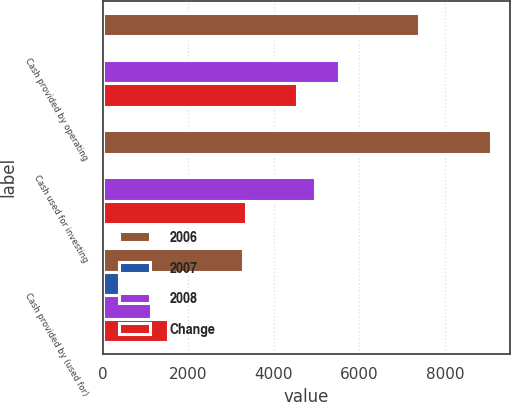Convert chart to OTSL. <chart><loc_0><loc_0><loc_500><loc_500><stacked_bar_chart><ecel><fcel>Cash provided by operating<fcel>Cash used for investing<fcel>Cash provided by (used for)<nl><fcel>2006<fcel>7402<fcel>9076<fcel>3281<nl><fcel>2007<fcel>34<fcel>83<fcel>388<nl><fcel>2008<fcel>5520<fcel>4971<fcel>1139<nl><fcel>Change<fcel>4541<fcel>3359<fcel>1527<nl></chart> 